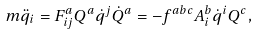Convert formula to latex. <formula><loc_0><loc_0><loc_500><loc_500>m \ddot { q } _ { i } = F _ { i j } ^ { a } Q ^ { a } \dot { q } ^ { j } \dot { Q } ^ { a } = - f ^ { a b c } A _ { i } ^ { b } \dot { q } ^ { i } Q ^ { c } ,</formula> 